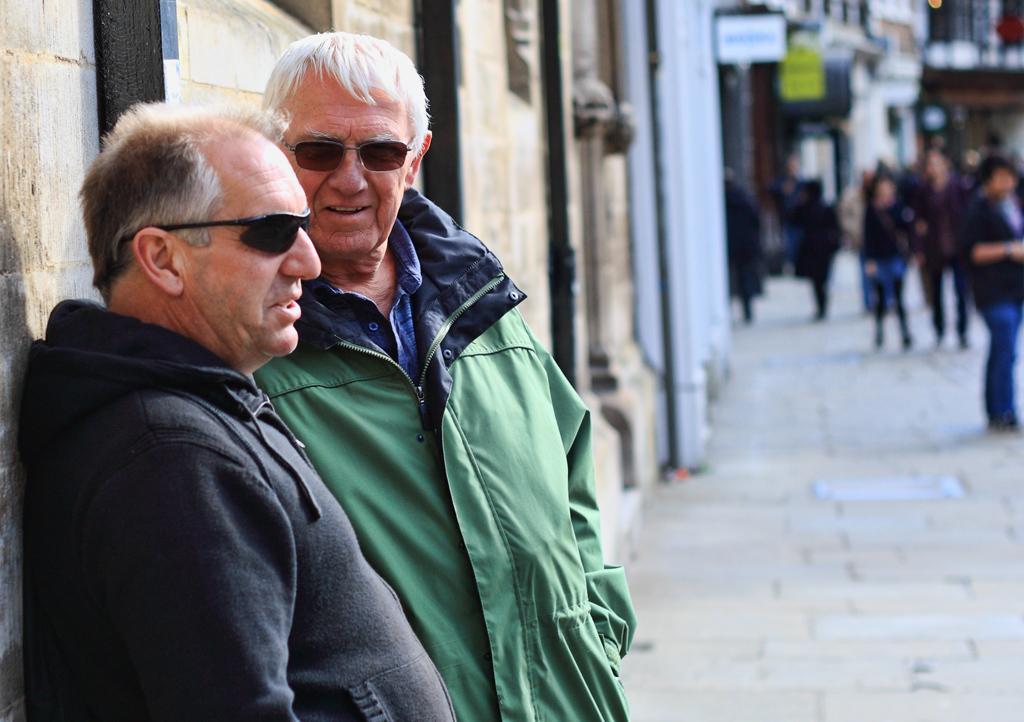Could you give a brief overview of what you see in this image? In the image we can see there are two people wearing clothes and goggle, they are talking to each other. There are even other people walking and some of them are standing, this is a building, board and a footpath. 